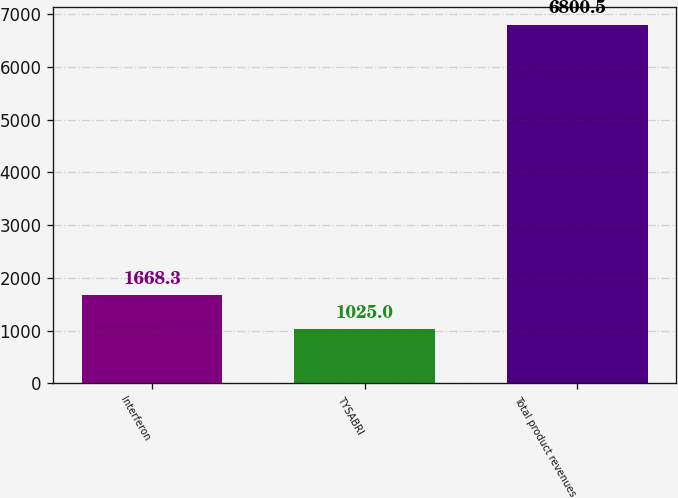Convert chart. <chart><loc_0><loc_0><loc_500><loc_500><bar_chart><fcel>Interferon<fcel>TYSABRI<fcel>Total product revenues<nl><fcel>1668.3<fcel>1025<fcel>6800.5<nl></chart> 